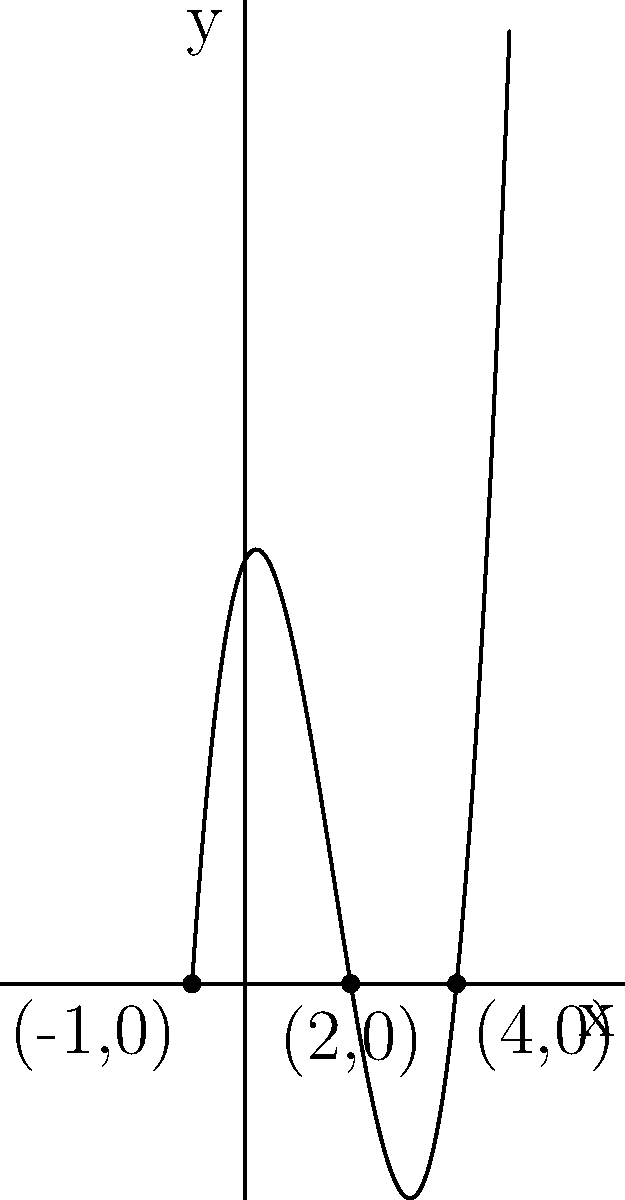Given the polynomial graph above, which of the following is true about the relationship between the polynomial's factors and its x-intercepts?

a) The x-intercepts are $(x+1)$, $(x-2)$, and $(x-4)$
b) The factors are $(x+1)$, $(x-2)$, and $(x-4)$
c) The x-intercepts are $-1$, $2$, and $4$
d) The factors are $-1$, $2$, and $4$ Let's approach this step-by-step:

1) First, we need to understand what x-intercepts and factors are:
   - x-intercepts are the points where the graph crosses the x-axis
   - factors are the terms that, when multiplied together, give us the polynomial

2) Looking at the graph, we can see that it crosses the x-axis at three points:
   $(-1,0)$, $(2,0)$, and $(4,0)$

3) These crossing points give us the x-intercepts: $-1$, $2$, and $4$

4) Now, how do these relate to the factors?
   - For each x-intercept $a$, there is a corresponding factor $(x-a)$
   - So, for $-1$, the factor is $(x-(-1))$ which simplifies to $(x+1)$
   - For $2$, the factor is $(x-2)$
   - For $4$, the factor is $(x-4)$

5) Therefore, the factors of the polynomial are $(x+1)$, $(x-2)$, and $(x-4)$

6) Comparing this to the given options:
   - Option a is incorrect because it confuses x-intercepts with factors
   - Option b correctly identifies the factors
   - Option c correctly identifies the x-intercepts
   - Option d is incorrect because it confuses factors with x-intercepts

So, while both options b and c are true statements, the question asks specifically about the relationship between factors and x-intercepts.
Answer: b) The factors are $(x+1)$, $(x-2)$, and $(x-4)$ 